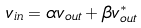<formula> <loc_0><loc_0><loc_500><loc_500>v _ { i n } = \alpha v _ { o u t } + \beta v _ { o u t } ^ { * }</formula> 